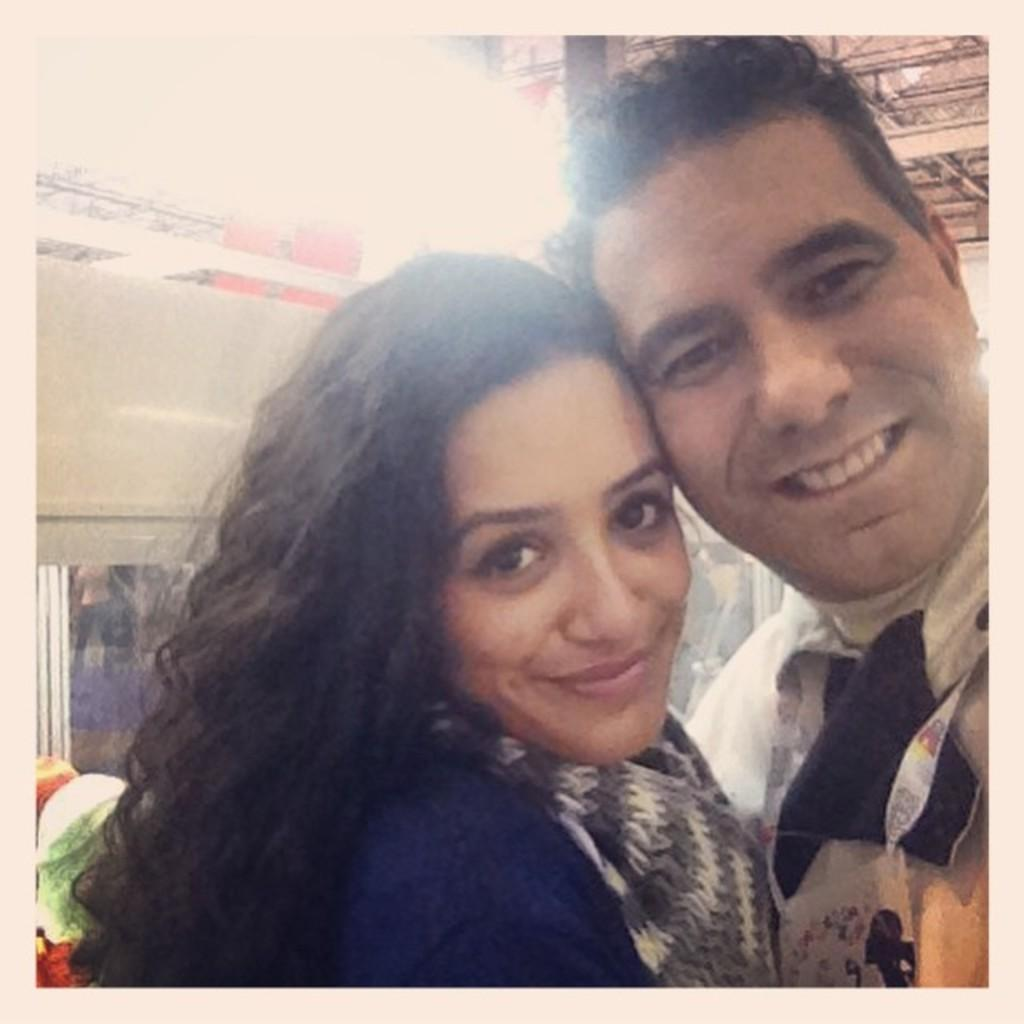How many people are in the image? There are two persons in the image. What can be seen in the background of the image? There is a wall with a window and a shed in the background of the image. Where is one of the persons located in relation to the window? One person is standing near the window. What type of lamp is being used for digestion in the image? There is no lamp or mention of digestion in the image. 